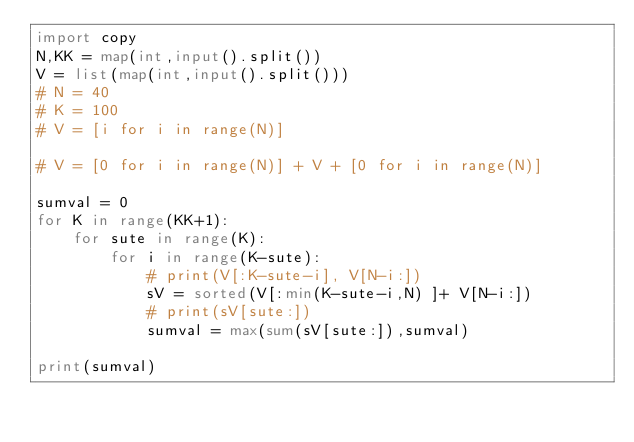<code> <loc_0><loc_0><loc_500><loc_500><_Python_>import copy
N,KK = map(int,input().split())
V = list(map(int,input().split()))
# N = 40
# K = 100
# V = [i for i in range(N)]

# V = [0 for i in range(N)] + V + [0 for i in range(N)] 

sumval = 0
for K in range(KK+1):
    for sute in range(K):
        for i in range(K-sute):
            # print(V[:K-sute-i], V[N-i:])
            sV = sorted(V[:min(K-sute-i,N) ]+ V[N-i:])
            # print(sV[sute:])
            sumval = max(sum(sV[sute:]),sumval)

print(sumval)</code> 